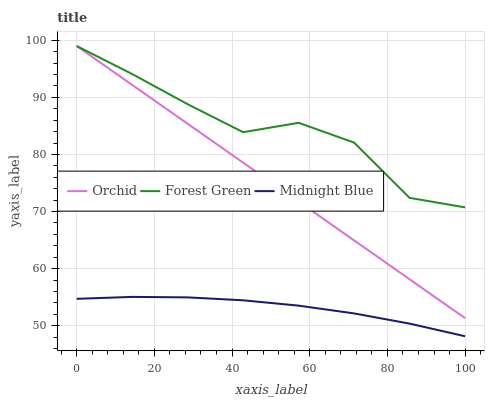Does Midnight Blue have the minimum area under the curve?
Answer yes or no. Yes. Does Forest Green have the maximum area under the curve?
Answer yes or no. Yes. Does Orchid have the minimum area under the curve?
Answer yes or no. No. Does Orchid have the maximum area under the curve?
Answer yes or no. No. Is Orchid the smoothest?
Answer yes or no. Yes. Is Forest Green the roughest?
Answer yes or no. Yes. Is Midnight Blue the smoothest?
Answer yes or no. No. Is Midnight Blue the roughest?
Answer yes or no. No. Does Orchid have the lowest value?
Answer yes or no. No. Does Orchid have the highest value?
Answer yes or no. Yes. Does Midnight Blue have the highest value?
Answer yes or no. No. Is Midnight Blue less than Forest Green?
Answer yes or no. Yes. Is Orchid greater than Midnight Blue?
Answer yes or no. Yes. Does Orchid intersect Forest Green?
Answer yes or no. Yes. Is Orchid less than Forest Green?
Answer yes or no. No. Is Orchid greater than Forest Green?
Answer yes or no. No. Does Midnight Blue intersect Forest Green?
Answer yes or no. No. 